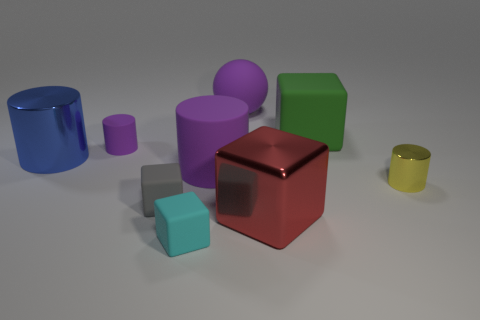Add 1 tiny gray objects. How many objects exist? 10 Subtract all cubes. How many objects are left? 5 Add 6 small gray rubber cubes. How many small gray rubber cubes exist? 7 Subtract 1 blue cylinders. How many objects are left? 8 Subtract all yellow cylinders. Subtract all large green matte things. How many objects are left? 7 Add 8 tiny yellow things. How many tiny yellow things are left? 9 